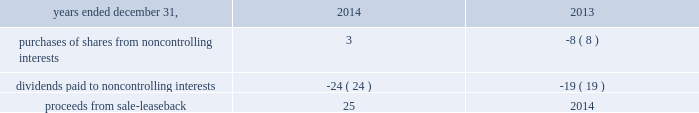Notes to consolidated financial statements 1 .
Basis of presentation the accompanying consolidated financial statements and notes thereto have been prepared in accordance with u.s .
Generally accepted accounting principles ( "u.s .
Gaap" ) .
The consolidated financial statements include the accounts of aon plc and all of its controlled subsidiaries ( "aon" or the "company" ) .
All intercompany accounts and transactions have been eliminated .
The consolidated financial statements include , in the opinion of management , all adjustments necessary to present fairly the company's consolidated financial position , results of operations and cash flows for all periods presented .
Reclassification certain amounts in prior years' consolidated financial statements and related notes have been reclassified to conform to the 2015 presentation .
In prior periods , long-term investments were included in investments in the consolidated statement of financial position .
These amounts are now included in other non-current assets in the consolidated statement of financial position , as shown in note 3 to these consolidated financial statements .
Long-term investments were $ 135 million at december 31 , 2015 and $ 143 million at december 31 , 2014 .
In prior periods , prepaid pensions were included in other non-current assets in the consolidated statement of financial position .
These amounts are now separately disclosed in the consolidated statement of financial position .
Prepaid pensions were $ 1033 million at december 31 , 2015 and $ 933 million at december 31 , 2014 .
Upon vesting of certain share-based payment arrangements , employees may elect to use a portion of the shares to satisfy tax withholding requirements , in which case aon makes a payment to the taxing authority on the employee 2019s behalf and remits the remaining shares to the employee .
The company has historically presented amounts due to taxing authorities within cash flows from operating activities in the consolidated statements of cash flows .
The amounts are now included in 201cissuance of shares for employee benefit plans 201d within cash flows from financing activities .
The company believes this presentation provides greater clarity into the operating and financing activities of the company as the substance and accounting for these transactions is that of a share repurchase .
It also aligns the company 2019s presentation to be consistent with industry practice .
Amounts reported in issuance of shares for employee benefit plans were $ 227 million , $ 170 million , and $ 120 million , respectively , for the years ended december 31 , 2015 , 2014 and 2013 .
These amounts , which were reclassified from accounts payable and accrued liabilities and other assets and liabilities , were $ 85 million and $ 85 million in 2014 , and $ 62 million and $ 58 million in 2013 , respectively .
Changes to the presentation in the consolidated statements of cash flows for 2014 and 2013 were made related to certain line items within financing activities .
The following line items and respective amounts have been aggregated in a new line item titled 201cnoncontrolling interests and other financing activities 201d within financing activities. .
Use of estimates the preparation of the accompanying consolidated financial statements in conformity with u.s .
Gaap requires management to make estimates and assumptions that affect the reported amounts of assets and liabilities , disclosures of contingent assets and liabilities at the date of the financial statements , and the reported amounts of reserves and expenses .
These estimates and assumptions are based on management's best estimates and judgments .
Management evaluates its estimates and assumptions on an ongoing basis using historical experience and other factors , including the current economic environment .
Management believes its estimates to be reasonable given the current facts available .
Aon adjusts such estimates and assumptions when facts and circumstances dictate .
Illiquid credit markets , volatile equity markets , and foreign currency exchange rate movements increase the uncertainty inherent in such estimates and assumptions .
As future events and their effects cannot be determined , among other factors , with precision , actual results could differ significantly from these estimates .
Changes in estimates resulting from continuing changes in the economic environment would , if applicable , be reflected in the financial statements in future periods. .
What is the net cash outflow reported for purchases of shares from noncontrolling interests and for dividends paid to noncontrolling interests? 
Computations: (3 + -24)
Answer: -21.0. Notes to consolidated financial statements 1 .
Basis of presentation the accompanying consolidated financial statements and notes thereto have been prepared in accordance with u.s .
Generally accepted accounting principles ( "u.s .
Gaap" ) .
The consolidated financial statements include the accounts of aon plc and all of its controlled subsidiaries ( "aon" or the "company" ) .
All intercompany accounts and transactions have been eliminated .
The consolidated financial statements include , in the opinion of management , all adjustments necessary to present fairly the company's consolidated financial position , results of operations and cash flows for all periods presented .
Reclassification certain amounts in prior years' consolidated financial statements and related notes have been reclassified to conform to the 2015 presentation .
In prior periods , long-term investments were included in investments in the consolidated statement of financial position .
These amounts are now included in other non-current assets in the consolidated statement of financial position , as shown in note 3 to these consolidated financial statements .
Long-term investments were $ 135 million at december 31 , 2015 and $ 143 million at december 31 , 2014 .
In prior periods , prepaid pensions were included in other non-current assets in the consolidated statement of financial position .
These amounts are now separately disclosed in the consolidated statement of financial position .
Prepaid pensions were $ 1033 million at december 31 , 2015 and $ 933 million at december 31 , 2014 .
Upon vesting of certain share-based payment arrangements , employees may elect to use a portion of the shares to satisfy tax withholding requirements , in which case aon makes a payment to the taxing authority on the employee 2019s behalf and remits the remaining shares to the employee .
The company has historically presented amounts due to taxing authorities within cash flows from operating activities in the consolidated statements of cash flows .
The amounts are now included in 201cissuance of shares for employee benefit plans 201d within cash flows from financing activities .
The company believes this presentation provides greater clarity into the operating and financing activities of the company as the substance and accounting for these transactions is that of a share repurchase .
It also aligns the company 2019s presentation to be consistent with industry practice .
Amounts reported in issuance of shares for employee benefit plans were $ 227 million , $ 170 million , and $ 120 million , respectively , for the years ended december 31 , 2015 , 2014 and 2013 .
These amounts , which were reclassified from accounts payable and accrued liabilities and other assets and liabilities , were $ 85 million and $ 85 million in 2014 , and $ 62 million and $ 58 million in 2013 , respectively .
Changes to the presentation in the consolidated statements of cash flows for 2014 and 2013 were made related to certain line items within financing activities .
The following line items and respective amounts have been aggregated in a new line item titled 201cnoncontrolling interests and other financing activities 201d within financing activities. .
Use of estimates the preparation of the accompanying consolidated financial statements in conformity with u.s .
Gaap requires management to make estimates and assumptions that affect the reported amounts of assets and liabilities , disclosures of contingent assets and liabilities at the date of the financial statements , and the reported amounts of reserves and expenses .
These estimates and assumptions are based on management's best estimates and judgments .
Management evaluates its estimates and assumptions on an ongoing basis using historical experience and other factors , including the current economic environment .
Management believes its estimates to be reasonable given the current facts available .
Aon adjusts such estimates and assumptions when facts and circumstances dictate .
Illiquid credit markets , volatile equity markets , and foreign currency exchange rate movements increase the uncertainty inherent in such estimates and assumptions .
As future events and their effects cannot be determined , among other factors , with precision , actual results could differ significantly from these estimates .
Changes in estimates resulting from continuing changes in the economic environment would , if applicable , be reflected in the financial statements in future periods. .
What is the total amount reported in issuance of shares for employee benefit plans in the last three years , ( in millions ) ? 
Computations: ((227 + 170) + 120)
Answer: 517.0. Notes to consolidated financial statements 1 .
Basis of presentation the accompanying consolidated financial statements and notes thereto have been prepared in accordance with u.s .
Generally accepted accounting principles ( "u.s .
Gaap" ) .
The consolidated financial statements include the accounts of aon plc and all of its controlled subsidiaries ( "aon" or the "company" ) .
All intercompany accounts and transactions have been eliminated .
The consolidated financial statements include , in the opinion of management , all adjustments necessary to present fairly the company's consolidated financial position , results of operations and cash flows for all periods presented .
Reclassification certain amounts in prior years' consolidated financial statements and related notes have been reclassified to conform to the 2015 presentation .
In prior periods , long-term investments were included in investments in the consolidated statement of financial position .
These amounts are now included in other non-current assets in the consolidated statement of financial position , as shown in note 3 to these consolidated financial statements .
Long-term investments were $ 135 million at december 31 , 2015 and $ 143 million at december 31 , 2014 .
In prior periods , prepaid pensions were included in other non-current assets in the consolidated statement of financial position .
These amounts are now separately disclosed in the consolidated statement of financial position .
Prepaid pensions were $ 1033 million at december 31 , 2015 and $ 933 million at december 31 , 2014 .
Upon vesting of certain share-based payment arrangements , employees may elect to use a portion of the shares to satisfy tax withholding requirements , in which case aon makes a payment to the taxing authority on the employee 2019s behalf and remits the remaining shares to the employee .
The company has historically presented amounts due to taxing authorities within cash flows from operating activities in the consolidated statements of cash flows .
The amounts are now included in 201cissuance of shares for employee benefit plans 201d within cash flows from financing activities .
The company believes this presentation provides greater clarity into the operating and financing activities of the company as the substance and accounting for these transactions is that of a share repurchase .
It also aligns the company 2019s presentation to be consistent with industry practice .
Amounts reported in issuance of shares for employee benefit plans were $ 227 million , $ 170 million , and $ 120 million , respectively , for the years ended december 31 , 2015 , 2014 and 2013 .
These amounts , which were reclassified from accounts payable and accrued liabilities and other assets and liabilities , were $ 85 million and $ 85 million in 2014 , and $ 62 million and $ 58 million in 2013 , respectively .
Changes to the presentation in the consolidated statements of cash flows for 2014 and 2013 were made related to certain line items within financing activities .
The following line items and respective amounts have been aggregated in a new line item titled 201cnoncontrolling interests and other financing activities 201d within financing activities. .
Use of estimates the preparation of the accompanying consolidated financial statements in conformity with u.s .
Gaap requires management to make estimates and assumptions that affect the reported amounts of assets and liabilities , disclosures of contingent assets and liabilities at the date of the financial statements , and the reported amounts of reserves and expenses .
These estimates and assumptions are based on management's best estimates and judgments .
Management evaluates its estimates and assumptions on an ongoing basis using historical experience and other factors , including the current economic environment .
Management believes its estimates to be reasonable given the current facts available .
Aon adjusts such estimates and assumptions when facts and circumstances dictate .
Illiquid credit markets , volatile equity markets , and foreign currency exchange rate movements increase the uncertainty inherent in such estimates and assumptions .
As future events and their effects cannot be determined , among other factors , with precision , actual results could differ significantly from these estimates .
Changes in estimates resulting from continuing changes in the economic environment would , if applicable , be reflected in the financial statements in future periods. .
What was the change in the long-term investments from 2014 to 2015 in millions? 
Computations: (135 - 143)
Answer: -8.0. 